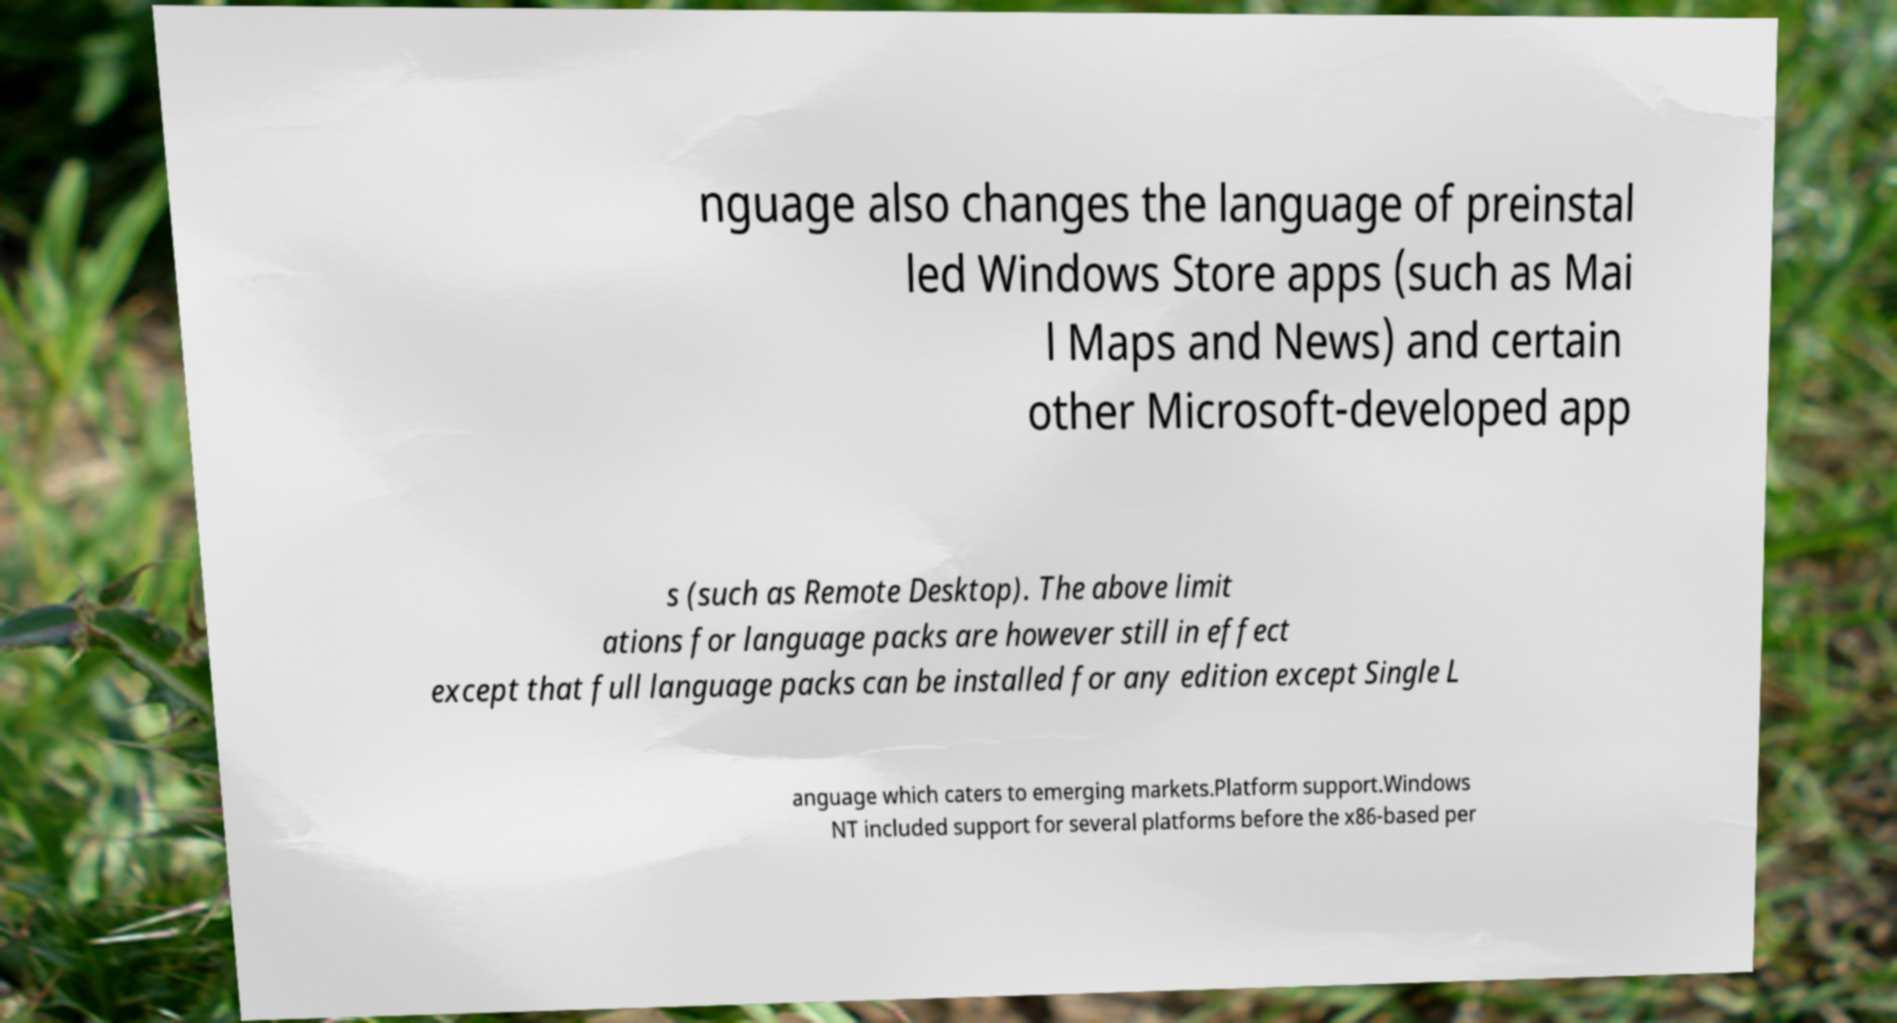Please identify and transcribe the text found in this image. nguage also changes the language of preinstal led Windows Store apps (such as Mai l Maps and News) and certain other Microsoft-developed app s (such as Remote Desktop). The above limit ations for language packs are however still in effect except that full language packs can be installed for any edition except Single L anguage which caters to emerging markets.Platform support.Windows NT included support for several platforms before the x86-based per 